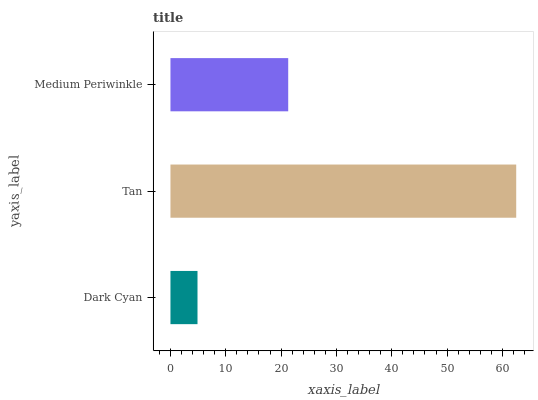Is Dark Cyan the minimum?
Answer yes or no. Yes. Is Tan the maximum?
Answer yes or no. Yes. Is Medium Periwinkle the minimum?
Answer yes or no. No. Is Medium Periwinkle the maximum?
Answer yes or no. No. Is Tan greater than Medium Periwinkle?
Answer yes or no. Yes. Is Medium Periwinkle less than Tan?
Answer yes or no. Yes. Is Medium Periwinkle greater than Tan?
Answer yes or no. No. Is Tan less than Medium Periwinkle?
Answer yes or no. No. Is Medium Periwinkle the high median?
Answer yes or no. Yes. Is Medium Periwinkle the low median?
Answer yes or no. Yes. Is Tan the high median?
Answer yes or no. No. Is Dark Cyan the low median?
Answer yes or no. No. 